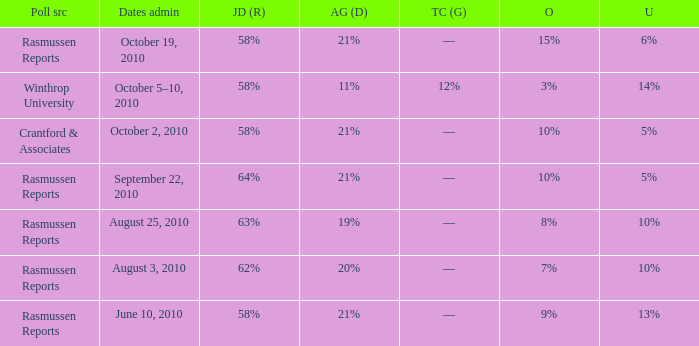What was the vote for Alvin Green when other was 9%? 21%. 